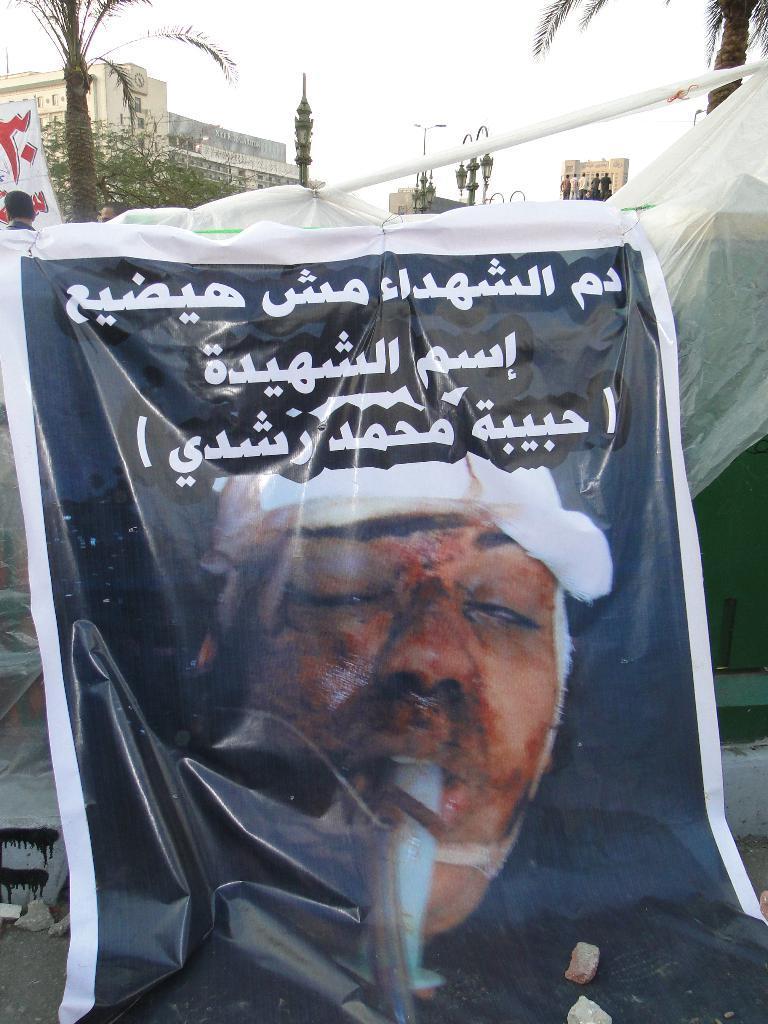Describe this image in one or two sentences. In this image we can see a banner with some text and a image of a person, in the background there is a cover, trees, light poles, buildings, few people and the sky. 